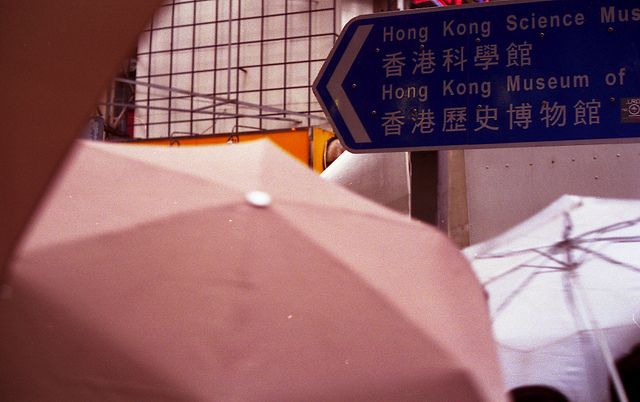Extract all visible text content from this image. Hong Kong Museum of Mus Science Kong Hong 